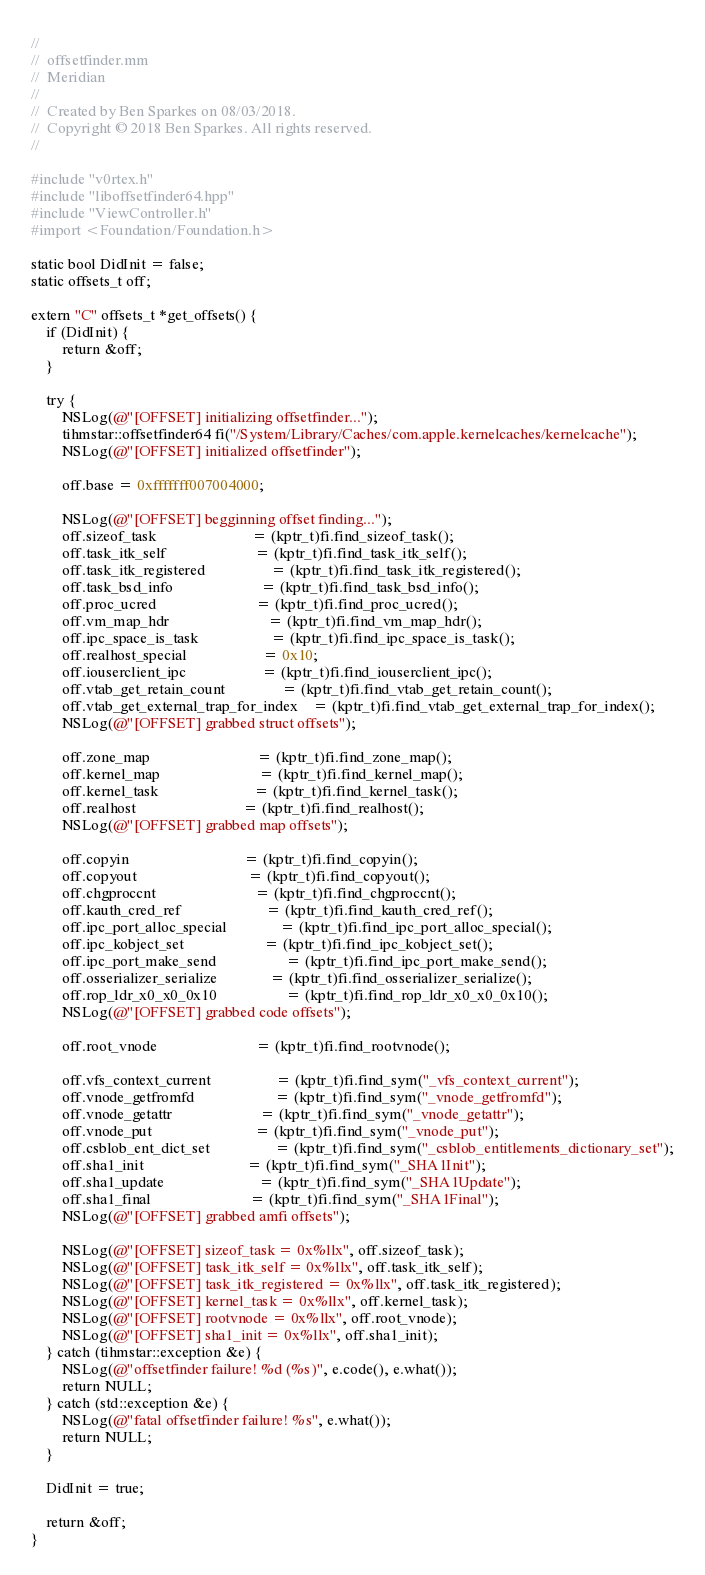Convert code to text. <code><loc_0><loc_0><loc_500><loc_500><_ObjectiveC_>//
//  offsetfinder.mm
//  Meridian
//
//  Created by Ben Sparkes on 08/03/2018.
//  Copyright © 2018 Ben Sparkes. All rights reserved.
//

#include "v0rtex.h"
#include "liboffsetfinder64.hpp"
#include "ViewController.h"
#import <Foundation/Foundation.h>

static bool DidInit = false;
static offsets_t off;

extern "C" offsets_t *get_offsets() {
    if (DidInit) {
        return &off;
    }

    try {
        NSLog(@"[OFFSET] initializing offsetfinder...");
        tihmstar::offsetfinder64 fi("/System/Library/Caches/com.apple.kernelcaches/kernelcache");
        NSLog(@"[OFFSET] initialized offsetfinder");

        off.base = 0xfffffff007004000;

        NSLog(@"[OFFSET] begginning offset finding...");
        off.sizeof_task                         = (kptr_t)fi.find_sizeof_task();
        off.task_itk_self                       = (kptr_t)fi.find_task_itk_self();
        off.task_itk_registered                 = (kptr_t)fi.find_task_itk_registered();
        off.task_bsd_info                       = (kptr_t)fi.find_task_bsd_info();
        off.proc_ucred                          = (kptr_t)fi.find_proc_ucred();
        off.vm_map_hdr                          = (kptr_t)fi.find_vm_map_hdr();
        off.ipc_space_is_task                   = (kptr_t)fi.find_ipc_space_is_task();
        off.realhost_special                    = 0x10;
        off.iouserclient_ipc                    = (kptr_t)fi.find_iouserclient_ipc();
        off.vtab_get_retain_count               = (kptr_t)fi.find_vtab_get_retain_count();
        off.vtab_get_external_trap_for_index    = (kptr_t)fi.find_vtab_get_external_trap_for_index();
        NSLog(@"[OFFSET] grabbed struct offsets");

        off.zone_map                            = (kptr_t)fi.find_zone_map();
        off.kernel_map                          = (kptr_t)fi.find_kernel_map();
        off.kernel_task                         = (kptr_t)fi.find_kernel_task();
        off.realhost                            = (kptr_t)fi.find_realhost();
        NSLog(@"[OFFSET] grabbed map offsets");
        
        off.copyin                              = (kptr_t)fi.find_copyin();
        off.copyout                             = (kptr_t)fi.find_copyout();
        off.chgproccnt                          = (kptr_t)fi.find_chgproccnt();
        off.kauth_cred_ref                      = (kptr_t)fi.find_kauth_cred_ref();
        off.ipc_port_alloc_special              = (kptr_t)fi.find_ipc_port_alloc_special();
        off.ipc_kobject_set                     = (kptr_t)fi.find_ipc_kobject_set();
        off.ipc_port_make_send                  = (kptr_t)fi.find_ipc_port_make_send();
        off.osserializer_serialize              = (kptr_t)fi.find_osserializer_serialize();
        off.rop_ldr_x0_x0_0x10                  = (kptr_t)fi.find_rop_ldr_x0_x0_0x10();
        NSLog(@"[OFFSET] grabbed code offsets");
        
        off.root_vnode                          = (kptr_t)fi.find_rootvnode();
        
        off.vfs_context_current                 = (kptr_t)fi.find_sym("_vfs_context_current");
        off.vnode_getfromfd                     = (kptr_t)fi.find_sym("_vnode_getfromfd");
        off.vnode_getattr                       = (kptr_t)fi.find_sym("_vnode_getattr");
        off.vnode_put                           = (kptr_t)fi.find_sym("_vnode_put");
        off.csblob_ent_dict_set                 = (kptr_t)fi.find_sym("_csblob_entitlements_dictionary_set");
        off.sha1_init                           = (kptr_t)fi.find_sym("_SHA1Init");
        off.sha1_update                         = (kptr_t)fi.find_sym("_SHA1Update");
        off.sha1_final                          = (kptr_t)fi.find_sym("_SHA1Final");
        NSLog(@"[OFFSET] grabbed amfi offsets");
        
        NSLog(@"[OFFSET] sizeof_task = 0x%llx", off.sizeof_task);
        NSLog(@"[OFFSET] task_itk_self = 0x%llx", off.task_itk_self);
        NSLog(@"[OFFSET] task_itk_registered = 0x%llx", off.task_itk_registered);
        NSLog(@"[OFFSET] kernel_task = 0x%llx", off.kernel_task);
        NSLog(@"[OFFSET] rootvnode = 0x%llx", off.root_vnode);
        NSLog(@"[OFFSET] sha1_init = 0x%llx", off.sha1_init);
    } catch (tihmstar::exception &e) {
        NSLog(@"offsetfinder failure! %d (%s)", e.code(), e.what());
        return NULL;
    } catch (std::exception &e) {
        NSLog(@"fatal offsetfinder failure! %s", e.what());
        return NULL;
    }
        
    DidInit = true;

    return &off;
}
</code> 